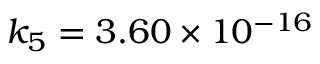Convert formula to latex. <formula><loc_0><loc_0><loc_500><loc_500>k _ { 5 } = 3 . 6 0 \times 1 0 ^ { - 1 6 }</formula> 